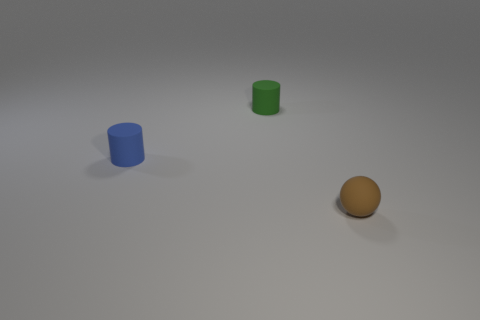Are there an equal number of small balls behind the blue cylinder and blue rubber cylinders in front of the ball?
Your answer should be compact. Yes. Are any small cyan metal cylinders visible?
Your response must be concise. No. What is the size of the matte cylinder that is behind the blue cylinder?
Your answer should be compact. Small. Are there more tiny things that are in front of the small green matte thing than big things?
Offer a very short reply. Yes. What is the shape of the brown thing?
Your answer should be very brief. Sphere. Is the blue object the same shape as the tiny brown object?
Keep it short and to the point. No. Is there any other thing that is the same shape as the blue rubber object?
Keep it short and to the point. Yes. Do the object right of the green cylinder and the tiny green cylinder have the same material?
Offer a very short reply. Yes. What shape is the object that is both behind the matte sphere and in front of the tiny green rubber object?
Your answer should be compact. Cylinder. Is there a tiny cylinder that is to the right of the object left of the tiny green thing?
Make the answer very short. Yes. 